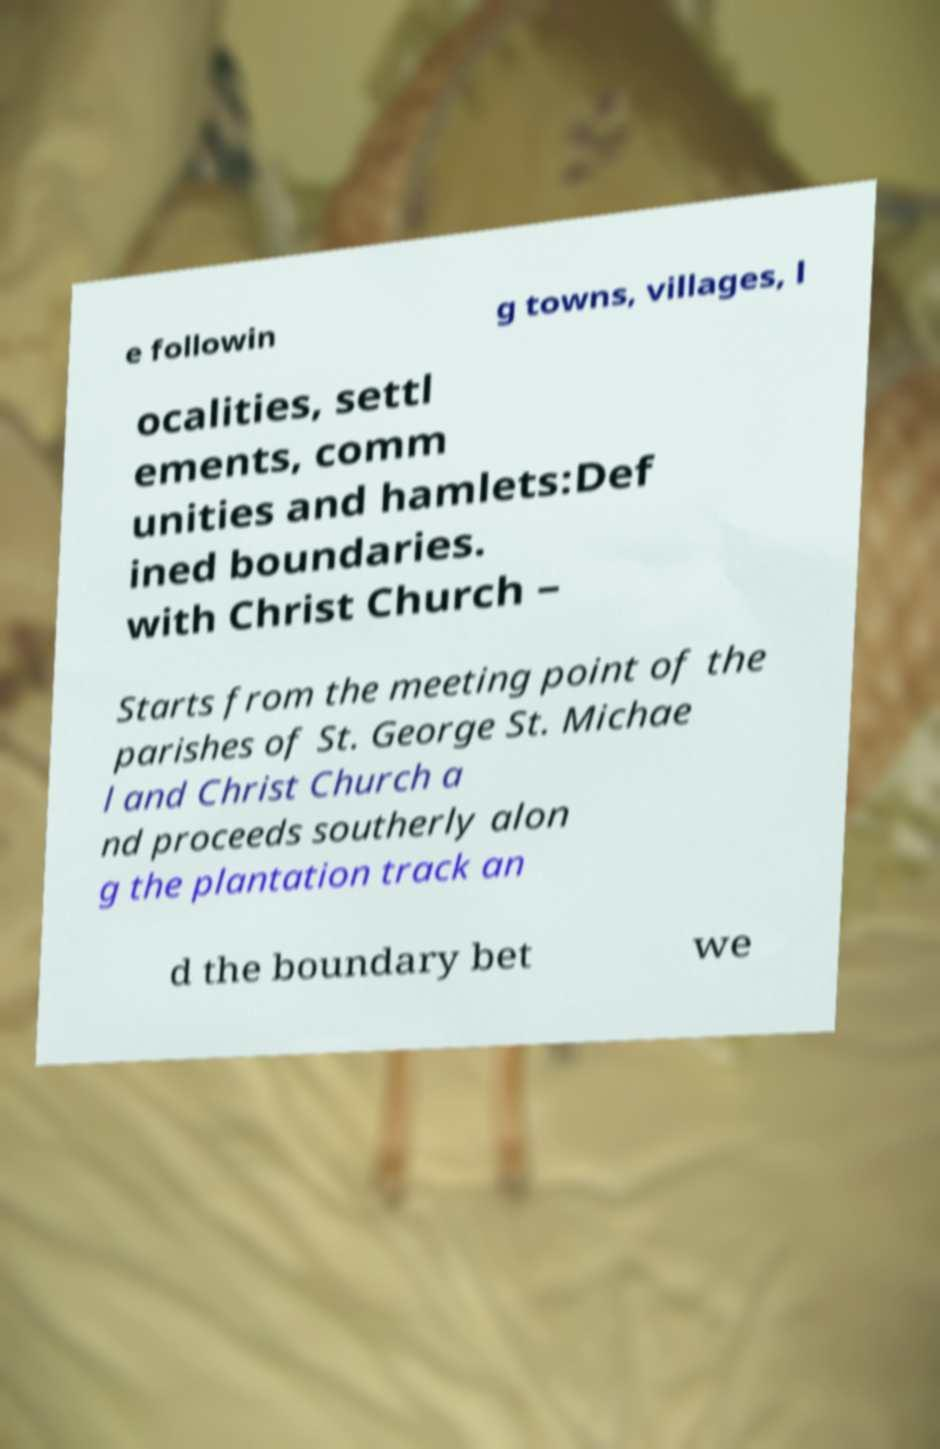Please identify and transcribe the text found in this image. e followin g towns, villages, l ocalities, settl ements, comm unities and hamlets:Def ined boundaries. with Christ Church – Starts from the meeting point of the parishes of St. George St. Michae l and Christ Church a nd proceeds southerly alon g the plantation track an d the boundary bet we 